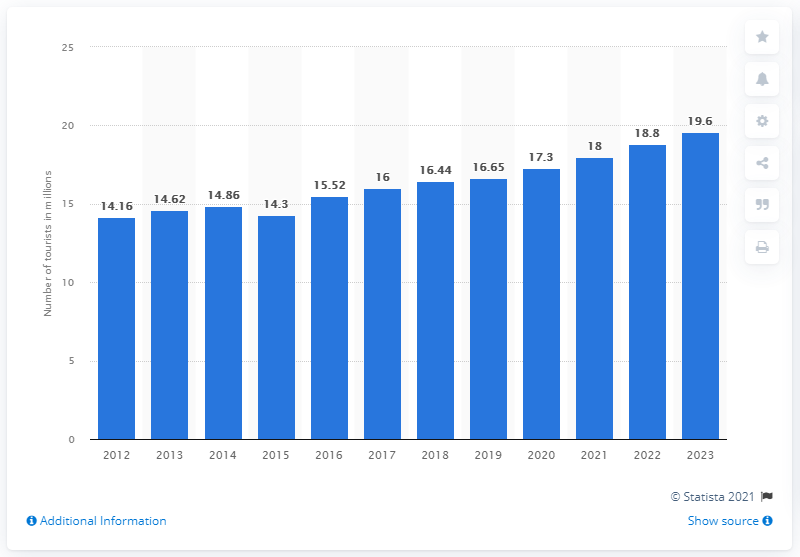Identify some key points in this picture. According to the forecast, the number of tourists in South Africa was expected to reach 19.6 by 2023. In 2018, the total number of tourists in South Africa was 16.44.. 